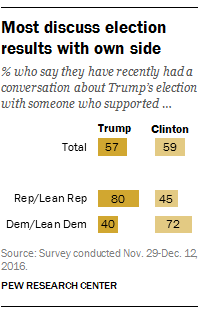List a handful of essential elements in this visual. A recent survey indicates that approximately 45% of Republican and Lean Republican respondents who recently discussed Trump's election with someone who supported Clinton hold opposing views. The maximum value of Trump bars is not equal to the minimum value of Clinton bars. 